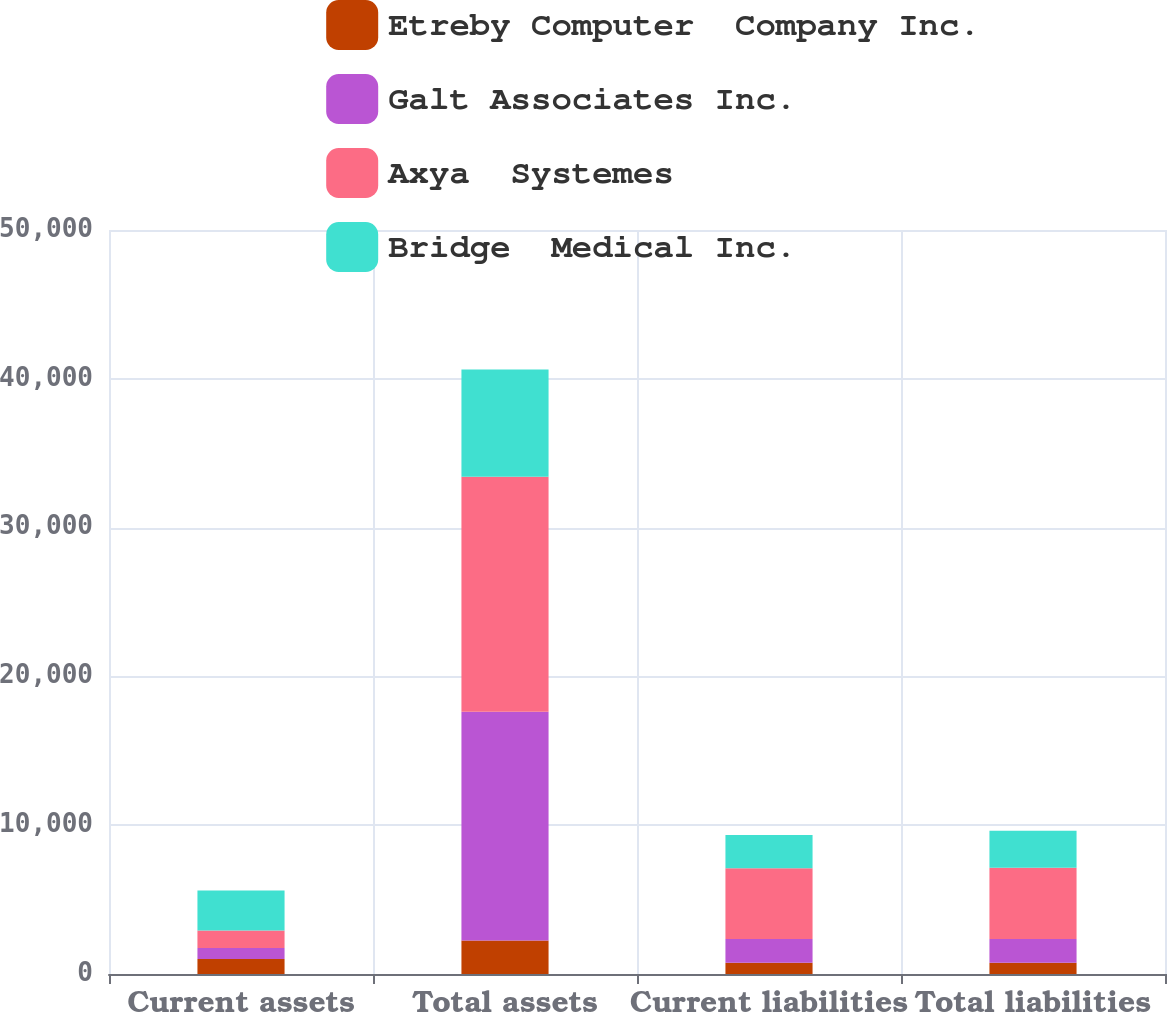<chart> <loc_0><loc_0><loc_500><loc_500><stacked_bar_chart><ecel><fcel>Current assets<fcel>Total assets<fcel>Current liabilities<fcel>Total liabilities<nl><fcel>Etreby Computer  Company Inc.<fcel>1002<fcel>2244<fcel>748<fcel>748<nl><fcel>Galt Associates Inc.<fcel>751<fcel>15372<fcel>1606<fcel>1606<nl><fcel>Axya  Systemes<fcel>1172<fcel>15802<fcel>4748<fcel>4783<nl><fcel>Bridge  Medical Inc.<fcel>2680<fcel>7209<fcel>2244<fcel>2483<nl></chart> 